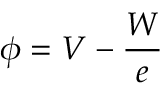Convert formula to latex. <formula><loc_0><loc_0><loc_500><loc_500>\phi = V - { \frac { W } { e } }</formula> 